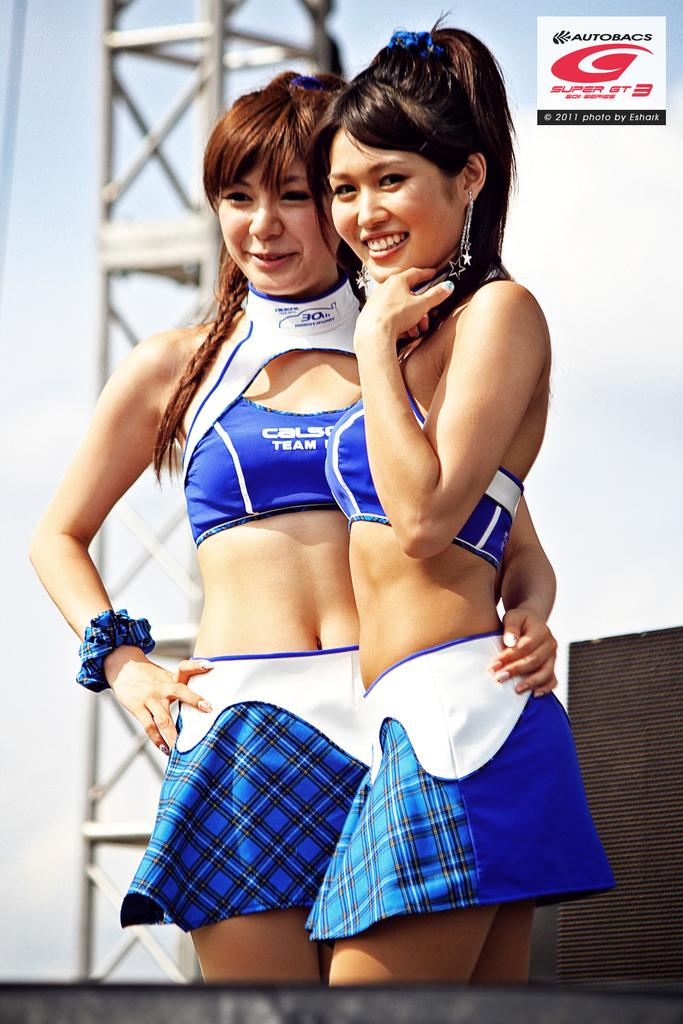Provide a one-sentence caption for the provided image. The brand shown here is Autobacs and it's their 30th anniversary. 